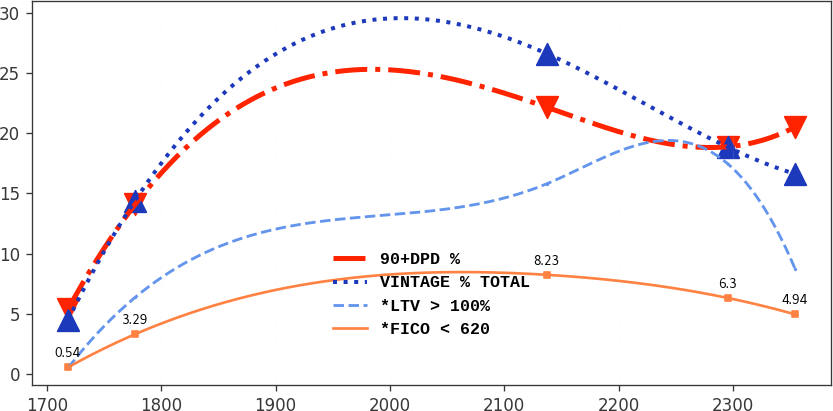Convert chart to OTSL. <chart><loc_0><loc_0><loc_500><loc_500><line_chart><ecel><fcel>90+DPD %<fcel>VINTAGE % TOTAL<fcel>*LTV > 100%<fcel>*FICO < 620<nl><fcel>1718.51<fcel>5.38<fcel>4.47<fcel>0.49<fcel>0.54<nl><fcel>1777.1<fcel>14.08<fcel>14.4<fcel>6.35<fcel>3.29<nl><fcel>2137.25<fcel>22.16<fcel>26.62<fcel>15.8<fcel>8.23<nl><fcel>2295.72<fcel>18.88<fcel>18.84<fcel>17.44<fcel>6.3<nl><fcel>2354.31<fcel>20.52<fcel>16.62<fcel>8.74<fcel>4.94<nl></chart> 